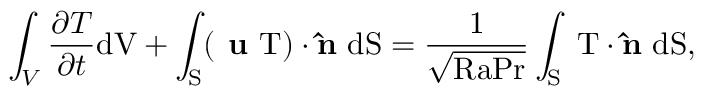<formula> <loc_0><loc_0><loc_500><loc_500>\int _ { V } \frac { \partial T } { \partial t } { d } V + \int _ { S } ( u T ) \cdot \hat { n } \ \mathrm { { d } S = \frac { 1 } { \sqrt { R a P r } } \int _ { S } \nabla T \cdot \hat { n } \ \mathrm { { d } S , } }</formula> 